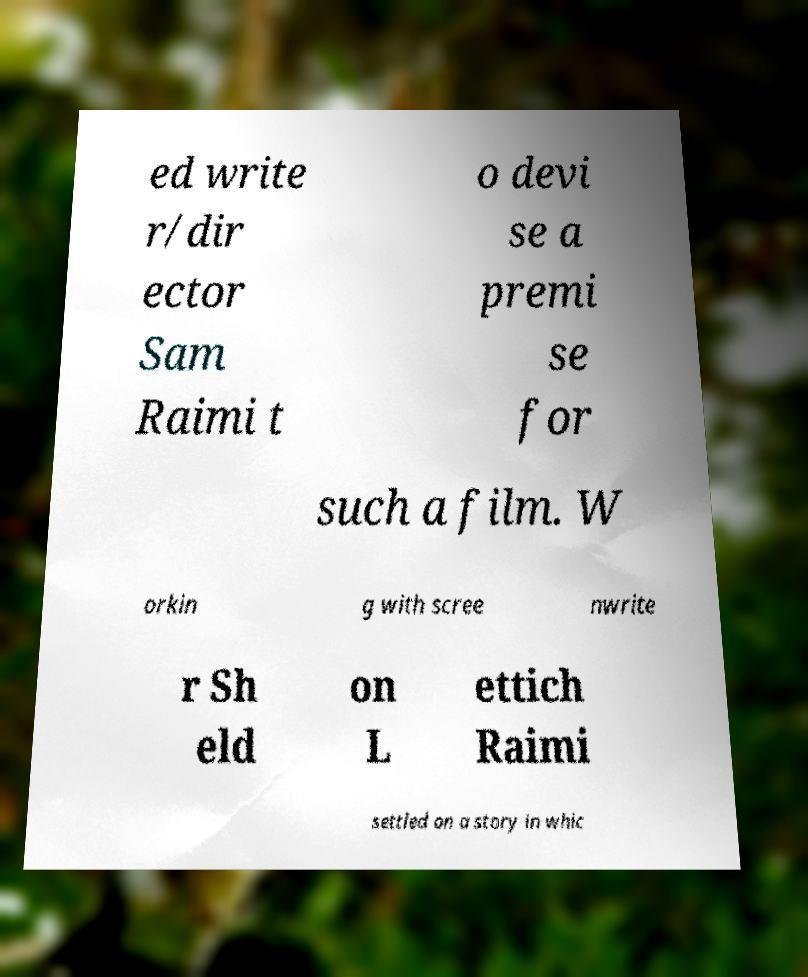What messages or text are displayed in this image? I need them in a readable, typed format. ed write r/dir ector Sam Raimi t o devi se a premi se for such a film. W orkin g with scree nwrite r Sh eld on L ettich Raimi settled on a story in whic 